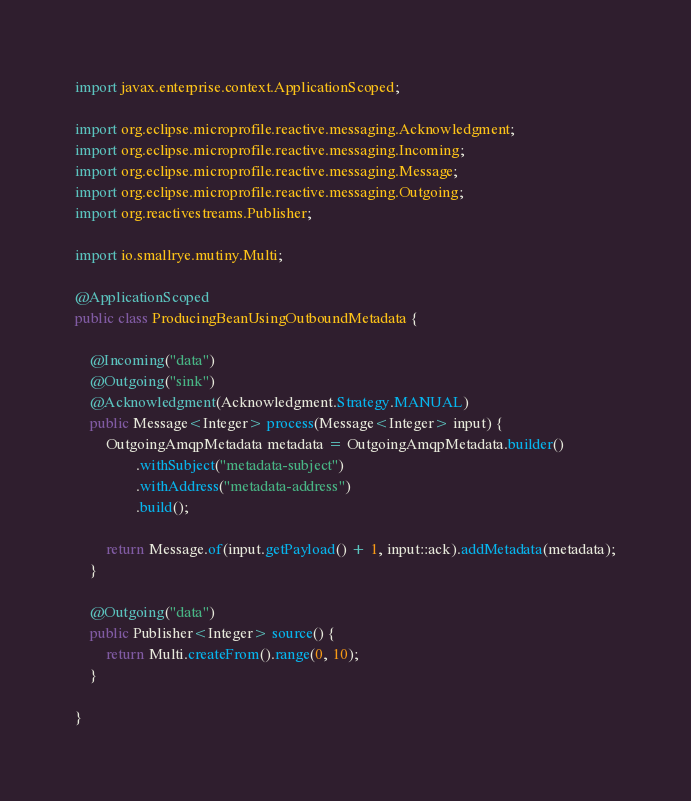<code> <loc_0><loc_0><loc_500><loc_500><_Java_>
import javax.enterprise.context.ApplicationScoped;

import org.eclipse.microprofile.reactive.messaging.Acknowledgment;
import org.eclipse.microprofile.reactive.messaging.Incoming;
import org.eclipse.microprofile.reactive.messaging.Message;
import org.eclipse.microprofile.reactive.messaging.Outgoing;
import org.reactivestreams.Publisher;

import io.smallrye.mutiny.Multi;

@ApplicationScoped
public class ProducingBeanUsingOutboundMetadata {

    @Incoming("data")
    @Outgoing("sink")
    @Acknowledgment(Acknowledgment.Strategy.MANUAL)
    public Message<Integer> process(Message<Integer> input) {
        OutgoingAmqpMetadata metadata = OutgoingAmqpMetadata.builder()
                .withSubject("metadata-subject")
                .withAddress("metadata-address")
                .build();

        return Message.of(input.getPayload() + 1, input::ack).addMetadata(metadata);
    }

    @Outgoing("data")
    public Publisher<Integer> source() {
        return Multi.createFrom().range(0, 10);
    }

}
</code> 